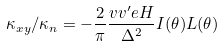Convert formula to latex. <formula><loc_0><loc_0><loc_500><loc_500>\kappa _ { x y } / \kappa _ { n } = - \frac { 2 } { \pi } \frac { v v ^ { \prime } e H } { \Delta ^ { 2 } } I ( \theta ) L ( \theta )</formula> 